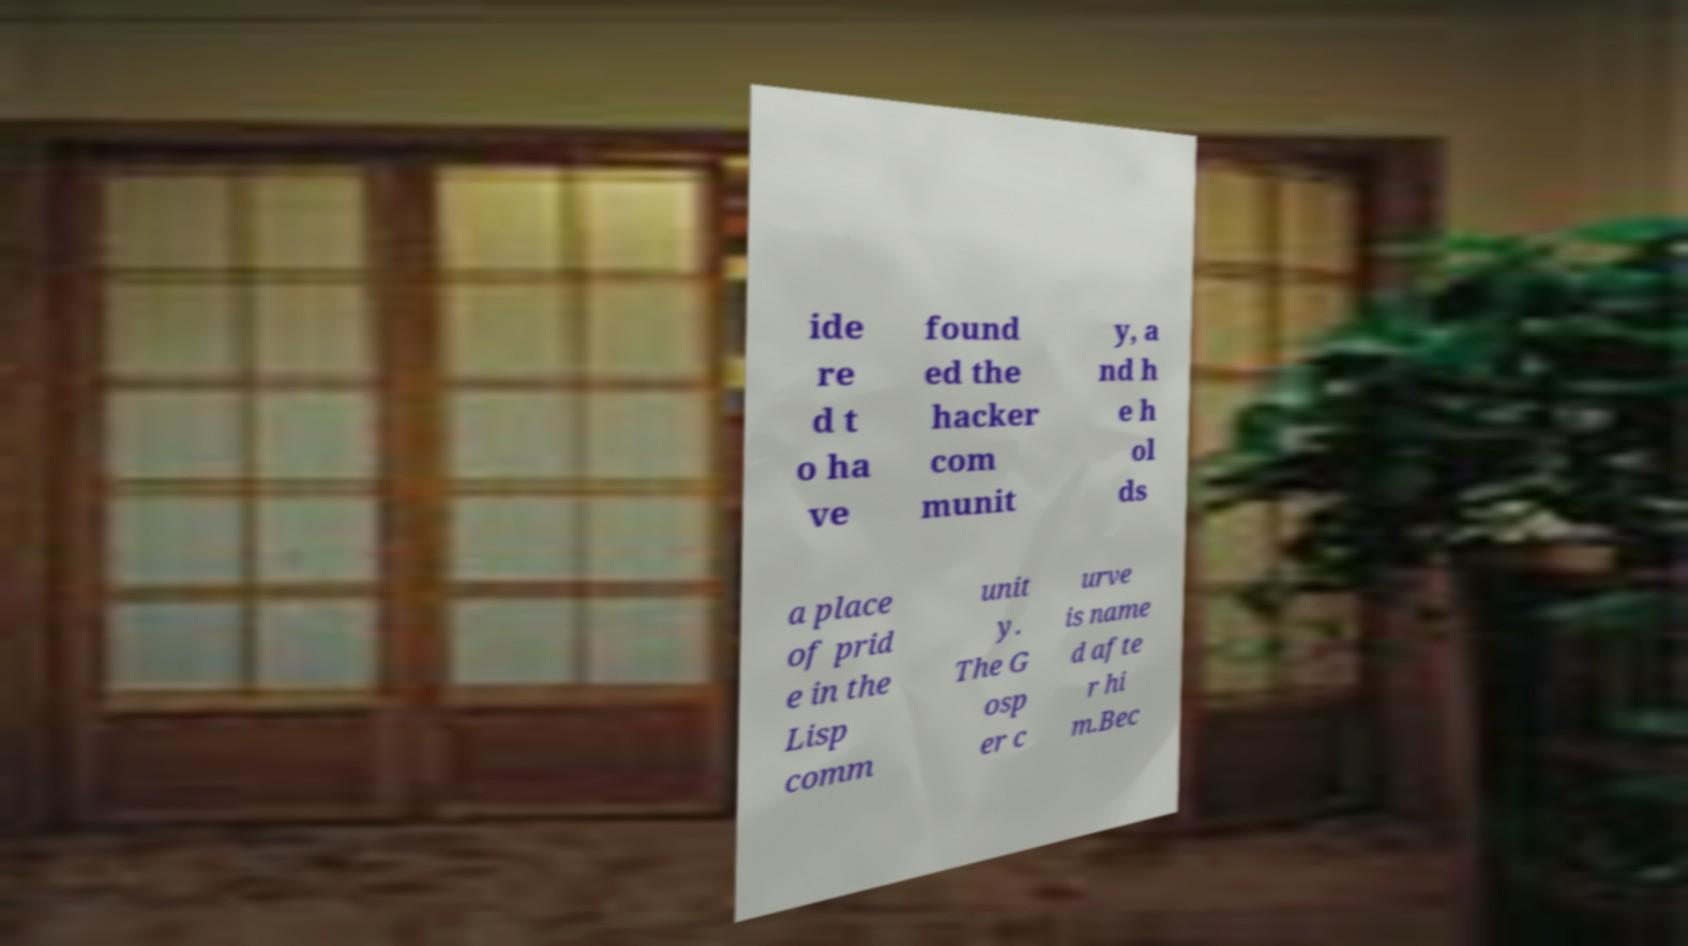Could you extract and type out the text from this image? ide re d t o ha ve found ed the hacker com munit y, a nd h e h ol ds a place of prid e in the Lisp comm unit y. The G osp er c urve is name d afte r hi m.Bec 